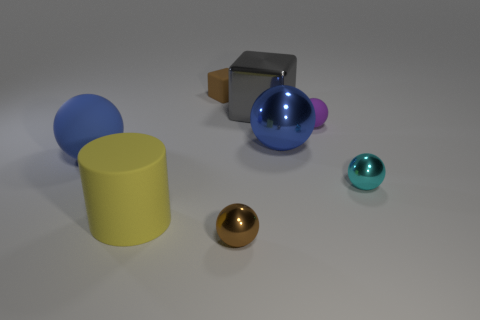Subtract 2 spheres. How many spheres are left? 3 Subtract all blue metallic spheres. How many spheres are left? 4 Subtract all cyan spheres. How many spheres are left? 4 Subtract all purple balls. Subtract all gray blocks. How many balls are left? 4 Add 2 big gray blocks. How many objects exist? 10 Subtract all cylinders. How many objects are left? 7 Subtract all large green metallic things. Subtract all tiny metallic balls. How many objects are left? 6 Add 7 yellow objects. How many yellow objects are left? 8 Add 4 large yellow things. How many large yellow things exist? 5 Subtract 0 red balls. How many objects are left? 8 